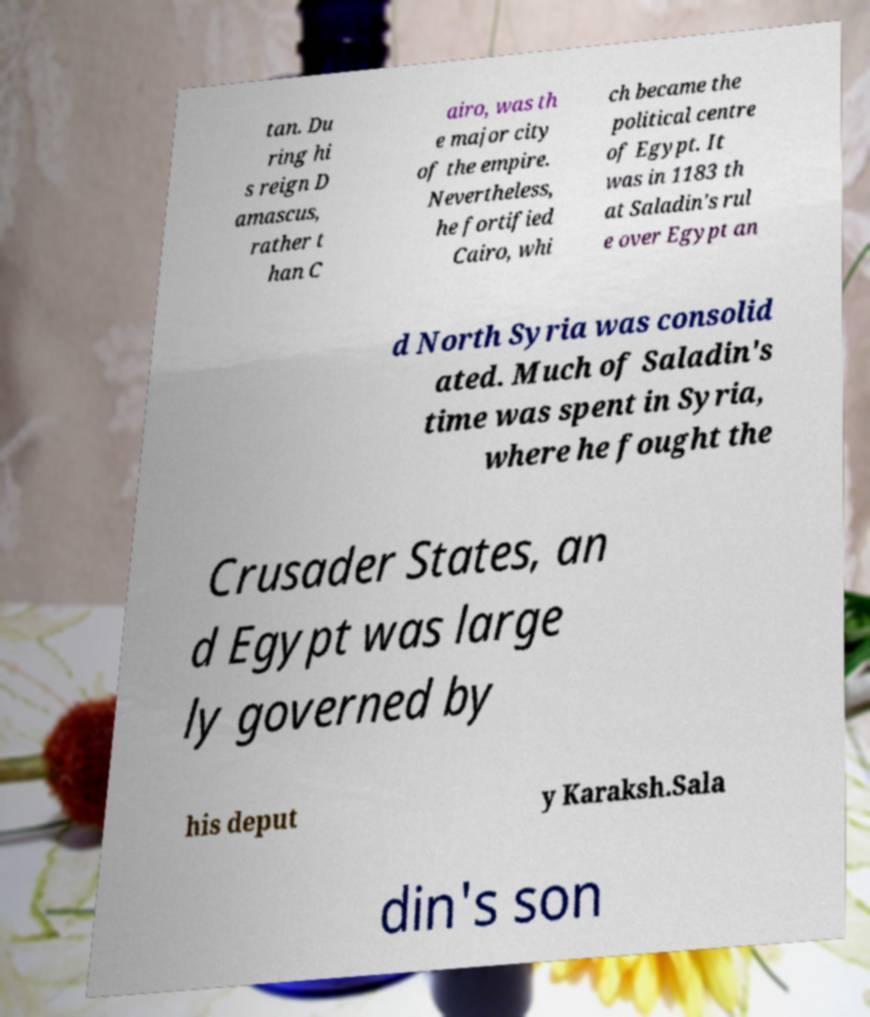For documentation purposes, I need the text within this image transcribed. Could you provide that? tan. Du ring hi s reign D amascus, rather t han C airo, was th e major city of the empire. Nevertheless, he fortified Cairo, whi ch became the political centre of Egypt. It was in 1183 th at Saladin's rul e over Egypt an d North Syria was consolid ated. Much of Saladin's time was spent in Syria, where he fought the Crusader States, an d Egypt was large ly governed by his deput y Karaksh.Sala din's son 